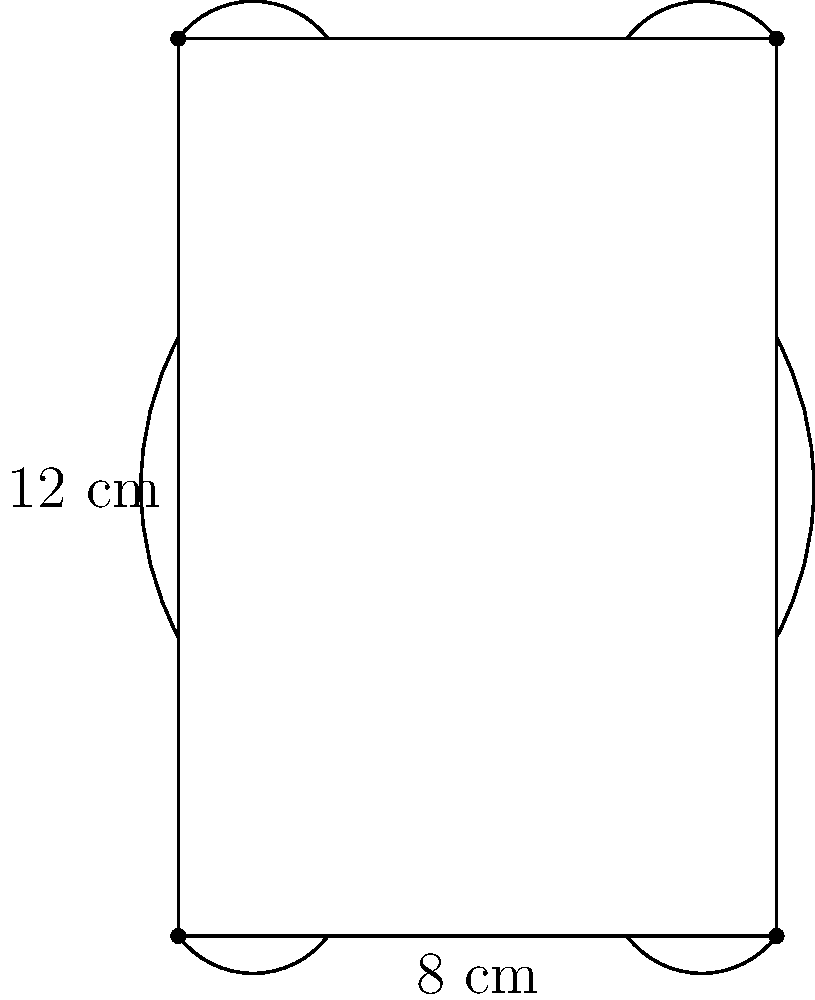A vintage book cover has ornate edges as shown in the diagram. The straight edges measure 8 cm in width and 12 cm in height. Each ornate curve adds approximately 0.5 cm to the length of the side it's on. What is the perimeter of this vintage book cover? Let's calculate the perimeter step by step:

1. First, we need to find the length of each side:
   - Width (top and bottom): $8 \text{ cm} + 0.5 \text{ cm} = 8.5 \text{ cm}$ each
   - Height (left and right): $12 \text{ cm} + 0.5 \text{ cm} = 12.5 \text{ cm}$ each

2. Now, we can add up all four sides:
   $$(8.5 \text{ cm} \times 2) + (12.5 \text{ cm} \times 2) = 17 \text{ cm} + 25 \text{ cm}$$

3. The total perimeter is:
   $$17 \text{ cm} + 25 \text{ cm} = 42 \text{ cm}$$

Therefore, the perimeter of the vintage book cover with ornate edges is 42 cm.
Answer: $42 \text{ cm}$ 